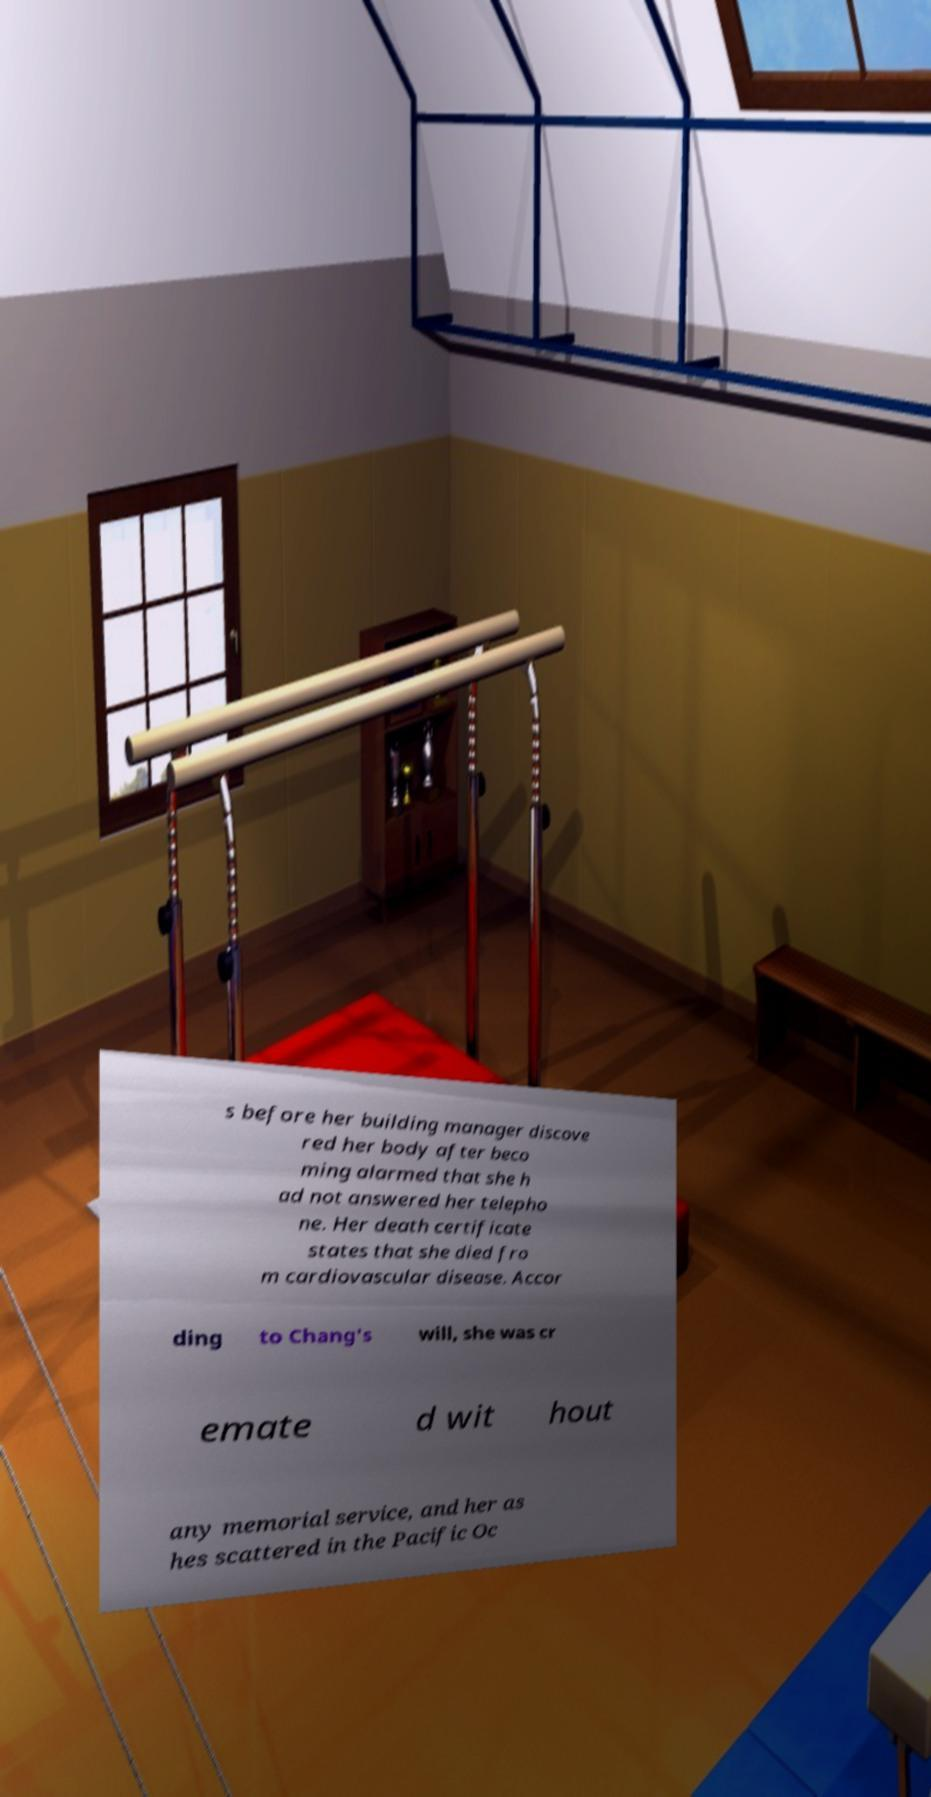Could you extract and type out the text from this image? s before her building manager discove red her body after beco ming alarmed that she h ad not answered her telepho ne. Her death certificate states that she died fro m cardiovascular disease. Accor ding to Chang's will, she was cr emate d wit hout any memorial service, and her as hes scattered in the Pacific Oc 